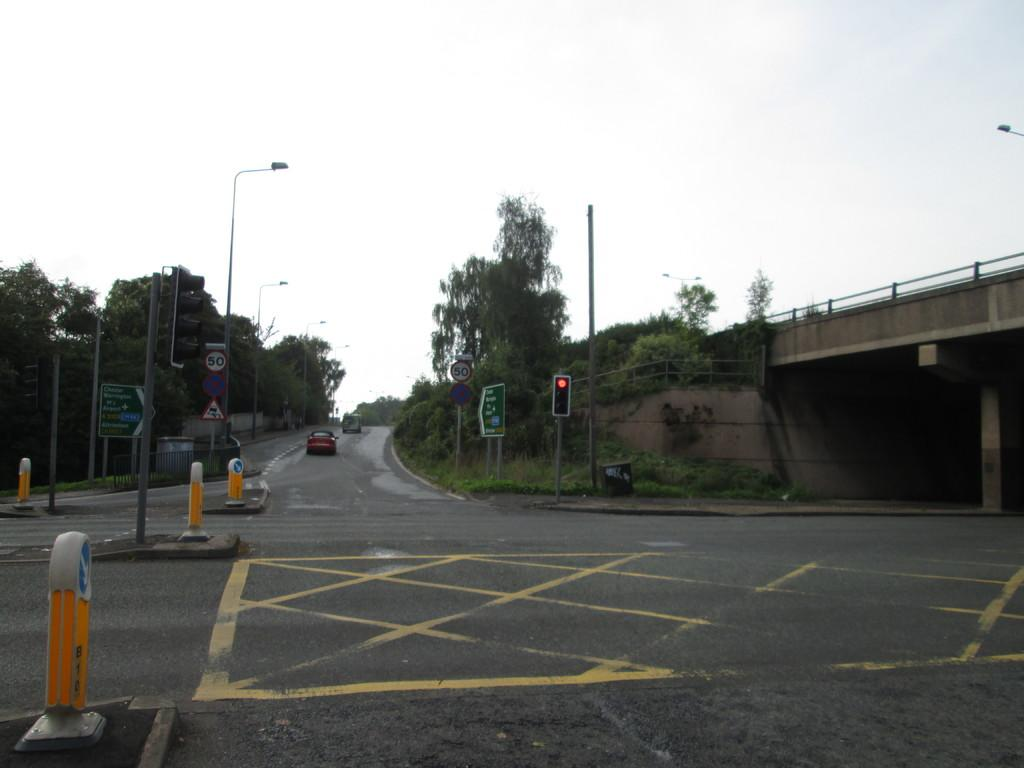What type of infrastructure is visible in the image? There is a road and a flyover in the image. What can be seen on both sides of the road? Trees and street lights are present on both sides of the road. What type of jewel is being exchanged between friends in the image? There are no friends or jewels present in the image; it features a road, a flyover, trees, and street lights. 